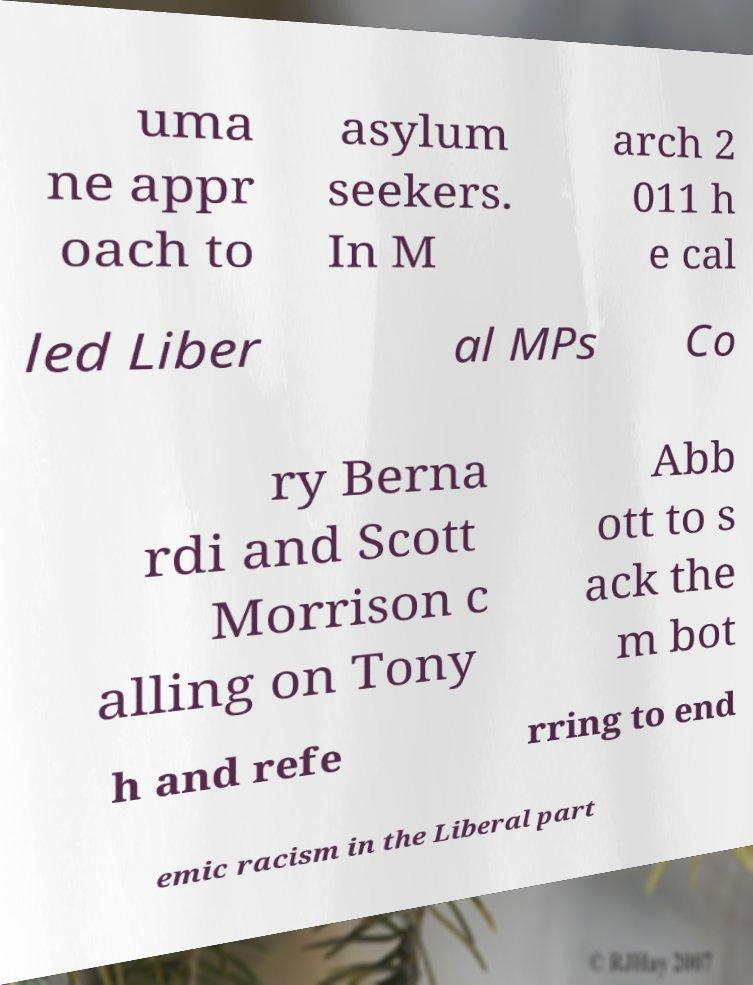Can you read and provide the text displayed in the image?This photo seems to have some interesting text. Can you extract and type it out for me? uma ne appr oach to asylum seekers. In M arch 2 011 h e cal led Liber al MPs Co ry Berna rdi and Scott Morrison c alling on Tony Abb ott to s ack the m bot h and refe rring to end emic racism in the Liberal part 